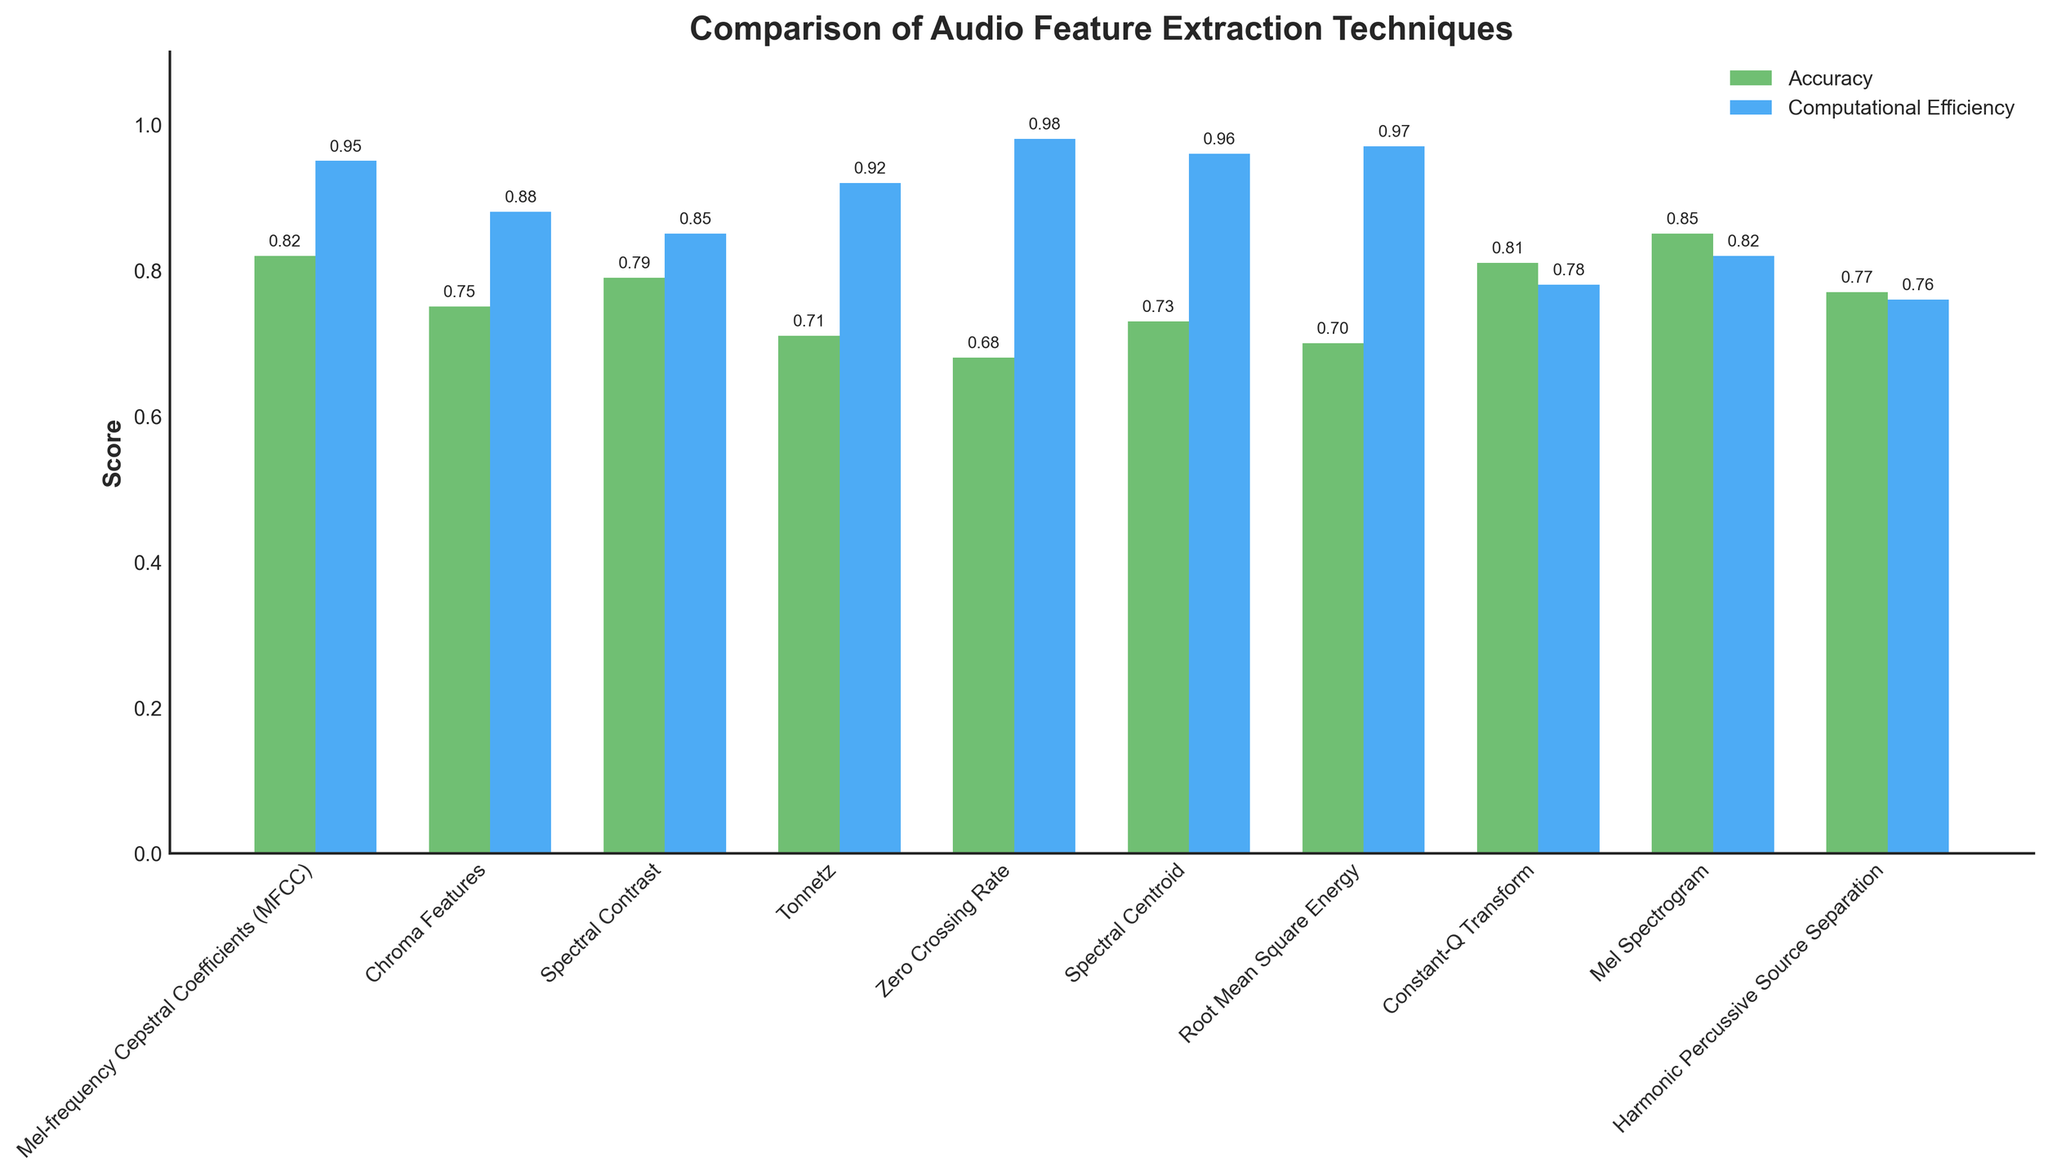Which technique has the highest accuracy? By observing the heights of the green bars, the highest bar represents the technique with the highest accuracy. The tallest green bar belongs to the Mel Spectrogram.
Answer: Mel Spectrogram Which technique has the lowest computational efficiency? By observing the heights of the blue bars, the shortest bar represents the technique with the lowest computational efficiency. The shortest blue bar belongs to the Harmonic Percussive Source Separation.
Answer: Harmonic Percussive Source Separation How many techniques have an accuracy greater than 0.80? Count the number of green bars that are taller than the 0.80 mark on the y-axis. The techniques that meet this criterion are Mel-frequency Cepstral Coefficients (MFCC), Constant-Q Transform, and Mel Spectrogram.
Answer: 3 What is the combined accuracy of Chroma Features and Spectral Contrast? Add the accuracy values of Chroma Features (0.75) and Spectral Contrast (0.79). The total is 0.75 + 0.79 = 1.54.
Answer: 1.54 Which technique has both high accuracy and high computational efficiency, being above 0.90 in efficiency? Look for a technique with both high green (accuracy) and blue (computational efficiency) bars above the 0.90 mark. Mel-frequency Cepstral Coefficients (MFCC) has accuracy 0.82 and computational efficiency 0.95.
Answer: Mel-frequency Cepstral Coefficients (MFCC) Between Zero Crossing Rate, Spectral Centroid, and Root Mean Square Energy, which has the highest accuracy? Compare the heights of the green bars corresponding to Zero Crossing Rate (0.68), Spectral Centroid (0.73), and Root Mean Square Energy (0.70). Spectral Centroid has the highest green bar.
Answer: Spectral Centroid Which technique has a higher computational efficiency, Tonnetz or Chroma Features? Compare the heights of the blue bars for Tonnetz (0.92) and Chroma Features (0.88). The blue bar for Tonnetz is taller.
Answer: Tonnetz What is the average computational efficiency of Mel-frequency Cepstral Coefficients (MFCC) and Mel Spectrogram? Add the computational efficiency values of MFCC (0.95) and Mel Spectrogram (0.82) and divide by 2. (0.95 + 0.82) / 2 = 0.885.
Answer: 0.885 Which technique has the lowest feature dimensionality and what is its accuracy? Examine the table for the technique with the lowest feature dimensionality, which is Zero Crossing Rate (1). Its accuracy, based on the green bar, is 0.68.
Answer: Zero Crossing Rate, 0.68 What is the difference in accuracy between Constant-Q Transform and Tonnetz? Subtract the accuracy values of Tonnetz (0.71) from Constant-Q Transform (0.81). 0.81 - 0.71 = 0.10.
Answer: 0.10 